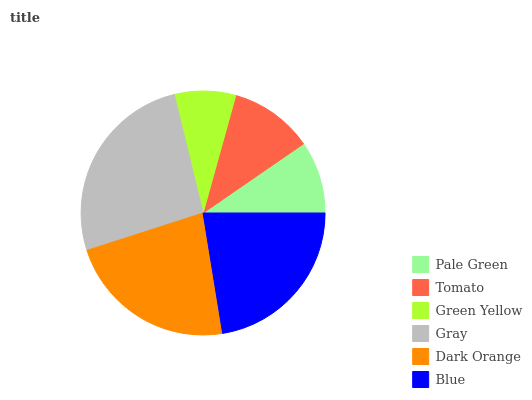Is Green Yellow the minimum?
Answer yes or no. Yes. Is Gray the maximum?
Answer yes or no. Yes. Is Tomato the minimum?
Answer yes or no. No. Is Tomato the maximum?
Answer yes or no. No. Is Tomato greater than Pale Green?
Answer yes or no. Yes. Is Pale Green less than Tomato?
Answer yes or no. Yes. Is Pale Green greater than Tomato?
Answer yes or no. No. Is Tomato less than Pale Green?
Answer yes or no. No. Is Blue the high median?
Answer yes or no. Yes. Is Tomato the low median?
Answer yes or no. Yes. Is Dark Orange the high median?
Answer yes or no. No. Is Green Yellow the low median?
Answer yes or no. No. 